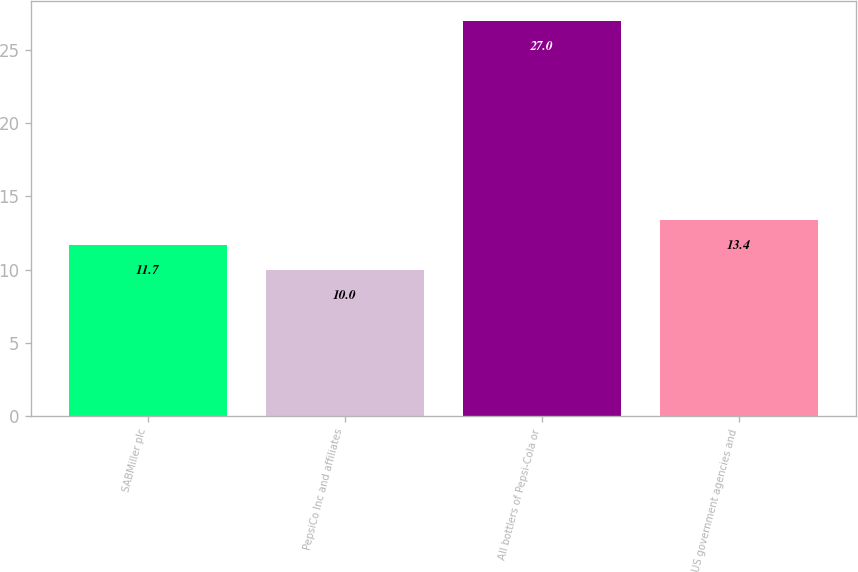<chart> <loc_0><loc_0><loc_500><loc_500><bar_chart><fcel>SABMiller plc<fcel>PepsiCo Inc and affiliates<fcel>All bottlers of Pepsi-Cola or<fcel>US government agencies and<nl><fcel>11.7<fcel>10<fcel>27<fcel>13.4<nl></chart> 